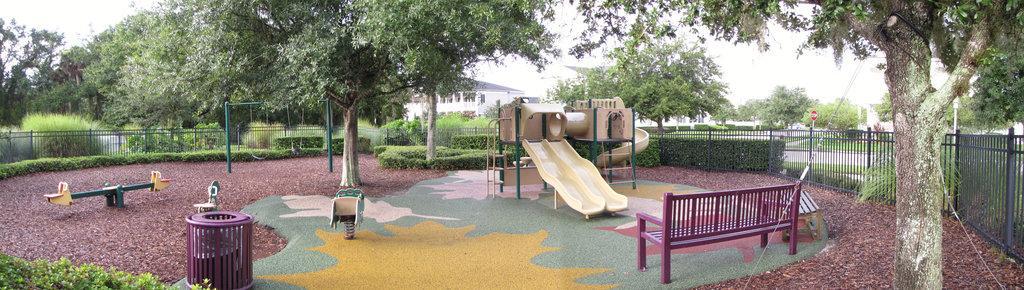How would you summarize this image in a sentence or two? I think this is the picture of the park. There are games, there is a bench in the middle and there is a railing. There are many trees, at the back of the trees there is a building, and at the top there is a sky. 